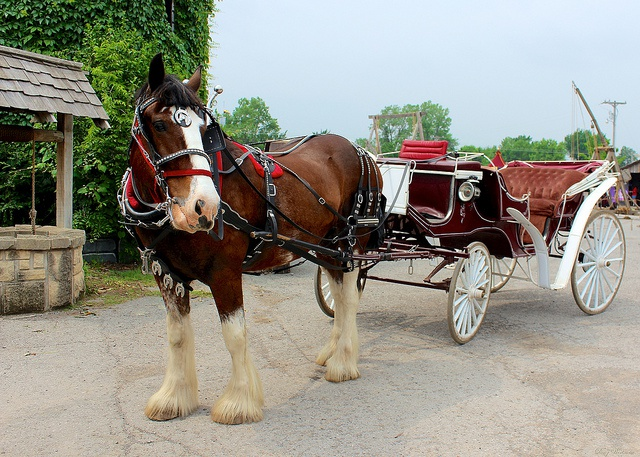Describe the objects in this image and their specific colors. I can see a horse in darkgreen, black, maroon, and tan tones in this image. 